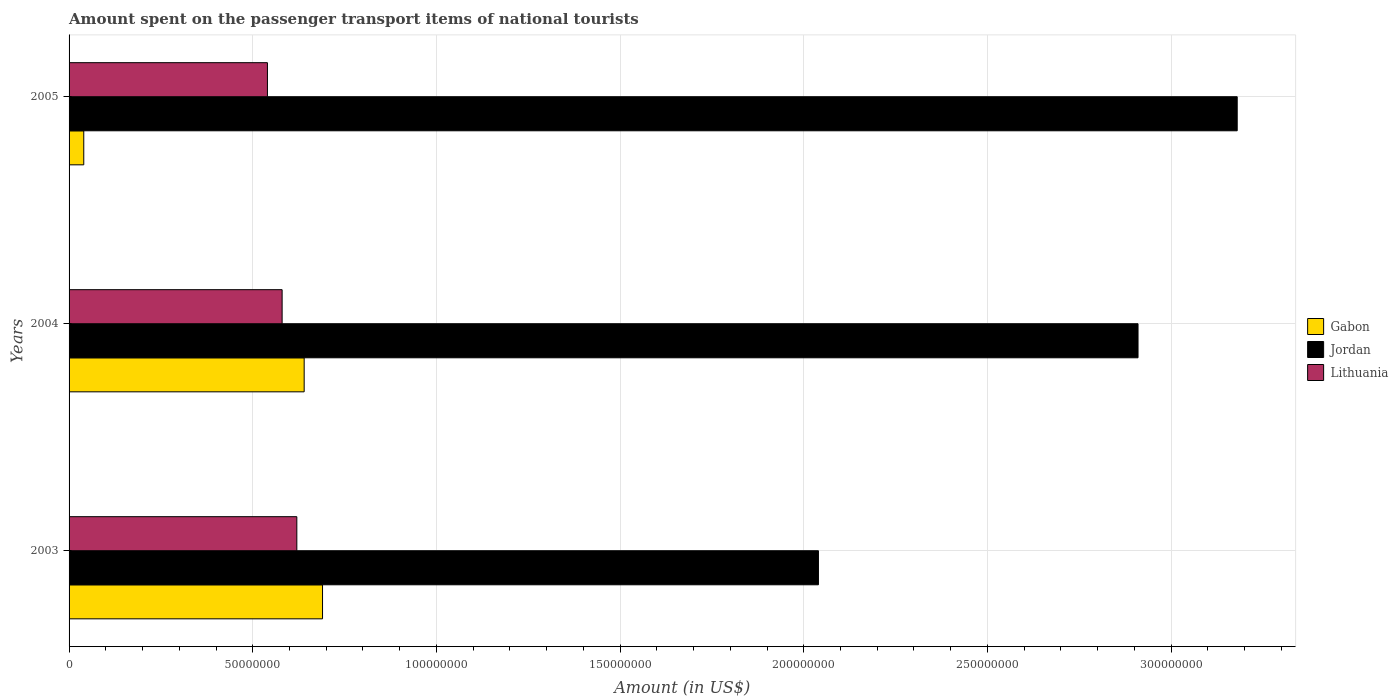How many groups of bars are there?
Your answer should be compact. 3. Are the number of bars per tick equal to the number of legend labels?
Provide a short and direct response. Yes. How many bars are there on the 3rd tick from the top?
Your answer should be compact. 3. What is the label of the 2nd group of bars from the top?
Make the answer very short. 2004. In how many cases, is the number of bars for a given year not equal to the number of legend labels?
Make the answer very short. 0. What is the amount spent on the passenger transport items of national tourists in Lithuania in 2003?
Ensure brevity in your answer.  6.20e+07. Across all years, what is the maximum amount spent on the passenger transport items of national tourists in Gabon?
Provide a short and direct response. 6.90e+07. Across all years, what is the minimum amount spent on the passenger transport items of national tourists in Jordan?
Provide a succinct answer. 2.04e+08. In which year was the amount spent on the passenger transport items of national tourists in Gabon minimum?
Keep it short and to the point. 2005. What is the total amount spent on the passenger transport items of national tourists in Gabon in the graph?
Ensure brevity in your answer.  1.37e+08. What is the difference between the amount spent on the passenger transport items of national tourists in Jordan in 2004 and that in 2005?
Offer a very short reply. -2.70e+07. What is the difference between the amount spent on the passenger transport items of national tourists in Lithuania in 2004 and the amount spent on the passenger transport items of national tourists in Jordan in 2005?
Ensure brevity in your answer.  -2.60e+08. What is the average amount spent on the passenger transport items of national tourists in Jordan per year?
Provide a succinct answer. 2.71e+08. In the year 2003, what is the difference between the amount spent on the passenger transport items of national tourists in Lithuania and amount spent on the passenger transport items of national tourists in Gabon?
Provide a succinct answer. -7.00e+06. In how many years, is the amount spent on the passenger transport items of national tourists in Lithuania greater than 290000000 US$?
Provide a succinct answer. 0. What is the ratio of the amount spent on the passenger transport items of national tourists in Lithuania in 2004 to that in 2005?
Provide a short and direct response. 1.07. Is the amount spent on the passenger transport items of national tourists in Gabon in 2003 less than that in 2004?
Your answer should be very brief. No. Is the difference between the amount spent on the passenger transport items of national tourists in Lithuania in 2004 and 2005 greater than the difference between the amount spent on the passenger transport items of national tourists in Gabon in 2004 and 2005?
Provide a short and direct response. No. What is the difference between the highest and the lowest amount spent on the passenger transport items of national tourists in Jordan?
Your response must be concise. 1.14e+08. In how many years, is the amount spent on the passenger transport items of national tourists in Gabon greater than the average amount spent on the passenger transport items of national tourists in Gabon taken over all years?
Offer a terse response. 2. What does the 1st bar from the top in 2003 represents?
Your answer should be compact. Lithuania. What does the 1st bar from the bottom in 2003 represents?
Offer a very short reply. Gabon. How many bars are there?
Your answer should be very brief. 9. Are all the bars in the graph horizontal?
Your response must be concise. Yes. Does the graph contain grids?
Ensure brevity in your answer.  Yes. Where does the legend appear in the graph?
Give a very brief answer. Center right. How many legend labels are there?
Make the answer very short. 3. What is the title of the graph?
Ensure brevity in your answer.  Amount spent on the passenger transport items of national tourists. Does "Argentina" appear as one of the legend labels in the graph?
Ensure brevity in your answer.  No. What is the label or title of the X-axis?
Offer a terse response. Amount (in US$). What is the label or title of the Y-axis?
Make the answer very short. Years. What is the Amount (in US$) in Gabon in 2003?
Make the answer very short. 6.90e+07. What is the Amount (in US$) of Jordan in 2003?
Provide a short and direct response. 2.04e+08. What is the Amount (in US$) of Lithuania in 2003?
Offer a very short reply. 6.20e+07. What is the Amount (in US$) in Gabon in 2004?
Your answer should be very brief. 6.40e+07. What is the Amount (in US$) in Jordan in 2004?
Keep it short and to the point. 2.91e+08. What is the Amount (in US$) of Lithuania in 2004?
Ensure brevity in your answer.  5.80e+07. What is the Amount (in US$) of Gabon in 2005?
Provide a succinct answer. 4.00e+06. What is the Amount (in US$) in Jordan in 2005?
Provide a succinct answer. 3.18e+08. What is the Amount (in US$) in Lithuania in 2005?
Keep it short and to the point. 5.40e+07. Across all years, what is the maximum Amount (in US$) in Gabon?
Make the answer very short. 6.90e+07. Across all years, what is the maximum Amount (in US$) in Jordan?
Your answer should be very brief. 3.18e+08. Across all years, what is the maximum Amount (in US$) in Lithuania?
Give a very brief answer. 6.20e+07. Across all years, what is the minimum Amount (in US$) in Jordan?
Ensure brevity in your answer.  2.04e+08. Across all years, what is the minimum Amount (in US$) of Lithuania?
Your answer should be compact. 5.40e+07. What is the total Amount (in US$) of Gabon in the graph?
Make the answer very short. 1.37e+08. What is the total Amount (in US$) in Jordan in the graph?
Your answer should be compact. 8.13e+08. What is the total Amount (in US$) in Lithuania in the graph?
Your answer should be compact. 1.74e+08. What is the difference between the Amount (in US$) in Jordan in 2003 and that in 2004?
Your response must be concise. -8.70e+07. What is the difference between the Amount (in US$) in Lithuania in 2003 and that in 2004?
Ensure brevity in your answer.  4.00e+06. What is the difference between the Amount (in US$) of Gabon in 2003 and that in 2005?
Provide a succinct answer. 6.50e+07. What is the difference between the Amount (in US$) of Jordan in 2003 and that in 2005?
Offer a terse response. -1.14e+08. What is the difference between the Amount (in US$) in Lithuania in 2003 and that in 2005?
Provide a short and direct response. 8.00e+06. What is the difference between the Amount (in US$) of Gabon in 2004 and that in 2005?
Your answer should be very brief. 6.00e+07. What is the difference between the Amount (in US$) in Jordan in 2004 and that in 2005?
Your answer should be compact. -2.70e+07. What is the difference between the Amount (in US$) of Gabon in 2003 and the Amount (in US$) of Jordan in 2004?
Your answer should be compact. -2.22e+08. What is the difference between the Amount (in US$) in Gabon in 2003 and the Amount (in US$) in Lithuania in 2004?
Provide a short and direct response. 1.10e+07. What is the difference between the Amount (in US$) of Jordan in 2003 and the Amount (in US$) of Lithuania in 2004?
Your response must be concise. 1.46e+08. What is the difference between the Amount (in US$) of Gabon in 2003 and the Amount (in US$) of Jordan in 2005?
Your answer should be compact. -2.49e+08. What is the difference between the Amount (in US$) of Gabon in 2003 and the Amount (in US$) of Lithuania in 2005?
Offer a terse response. 1.50e+07. What is the difference between the Amount (in US$) of Jordan in 2003 and the Amount (in US$) of Lithuania in 2005?
Keep it short and to the point. 1.50e+08. What is the difference between the Amount (in US$) in Gabon in 2004 and the Amount (in US$) in Jordan in 2005?
Keep it short and to the point. -2.54e+08. What is the difference between the Amount (in US$) of Gabon in 2004 and the Amount (in US$) of Lithuania in 2005?
Your answer should be very brief. 1.00e+07. What is the difference between the Amount (in US$) of Jordan in 2004 and the Amount (in US$) of Lithuania in 2005?
Make the answer very short. 2.37e+08. What is the average Amount (in US$) in Gabon per year?
Ensure brevity in your answer.  4.57e+07. What is the average Amount (in US$) in Jordan per year?
Give a very brief answer. 2.71e+08. What is the average Amount (in US$) in Lithuania per year?
Your answer should be compact. 5.80e+07. In the year 2003, what is the difference between the Amount (in US$) in Gabon and Amount (in US$) in Jordan?
Give a very brief answer. -1.35e+08. In the year 2003, what is the difference between the Amount (in US$) in Gabon and Amount (in US$) in Lithuania?
Your response must be concise. 7.00e+06. In the year 2003, what is the difference between the Amount (in US$) of Jordan and Amount (in US$) of Lithuania?
Give a very brief answer. 1.42e+08. In the year 2004, what is the difference between the Amount (in US$) in Gabon and Amount (in US$) in Jordan?
Provide a short and direct response. -2.27e+08. In the year 2004, what is the difference between the Amount (in US$) in Gabon and Amount (in US$) in Lithuania?
Offer a terse response. 6.00e+06. In the year 2004, what is the difference between the Amount (in US$) in Jordan and Amount (in US$) in Lithuania?
Provide a short and direct response. 2.33e+08. In the year 2005, what is the difference between the Amount (in US$) in Gabon and Amount (in US$) in Jordan?
Offer a very short reply. -3.14e+08. In the year 2005, what is the difference between the Amount (in US$) of Gabon and Amount (in US$) of Lithuania?
Offer a very short reply. -5.00e+07. In the year 2005, what is the difference between the Amount (in US$) in Jordan and Amount (in US$) in Lithuania?
Offer a terse response. 2.64e+08. What is the ratio of the Amount (in US$) in Gabon in 2003 to that in 2004?
Your response must be concise. 1.08. What is the ratio of the Amount (in US$) in Jordan in 2003 to that in 2004?
Offer a very short reply. 0.7. What is the ratio of the Amount (in US$) of Lithuania in 2003 to that in 2004?
Provide a short and direct response. 1.07. What is the ratio of the Amount (in US$) of Gabon in 2003 to that in 2005?
Give a very brief answer. 17.25. What is the ratio of the Amount (in US$) in Jordan in 2003 to that in 2005?
Keep it short and to the point. 0.64. What is the ratio of the Amount (in US$) in Lithuania in 2003 to that in 2005?
Offer a very short reply. 1.15. What is the ratio of the Amount (in US$) in Gabon in 2004 to that in 2005?
Provide a short and direct response. 16. What is the ratio of the Amount (in US$) of Jordan in 2004 to that in 2005?
Your response must be concise. 0.92. What is the ratio of the Amount (in US$) of Lithuania in 2004 to that in 2005?
Give a very brief answer. 1.07. What is the difference between the highest and the second highest Amount (in US$) of Jordan?
Your response must be concise. 2.70e+07. What is the difference between the highest and the lowest Amount (in US$) of Gabon?
Provide a succinct answer. 6.50e+07. What is the difference between the highest and the lowest Amount (in US$) of Jordan?
Provide a short and direct response. 1.14e+08. What is the difference between the highest and the lowest Amount (in US$) of Lithuania?
Offer a terse response. 8.00e+06. 